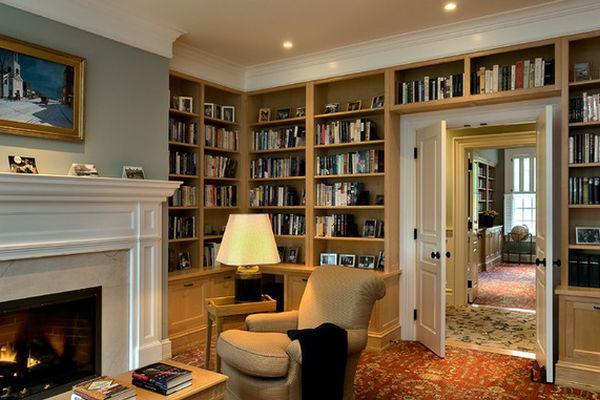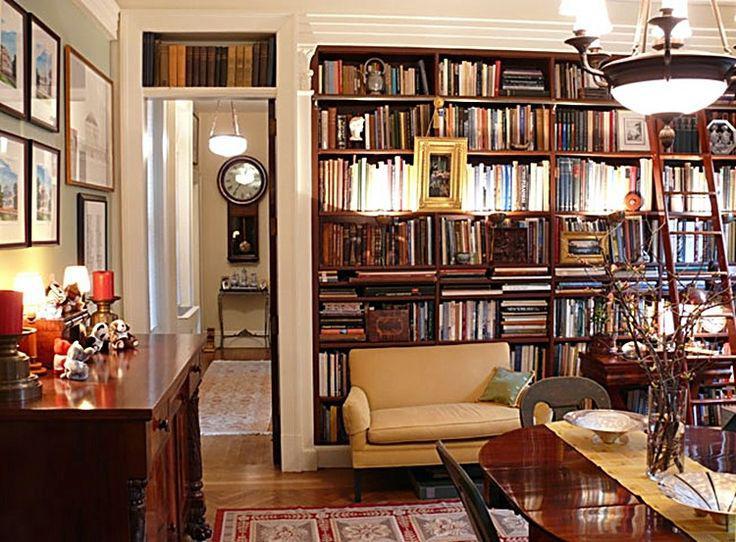The first image is the image on the left, the second image is the image on the right. Analyze the images presented: Is the assertion "There are at most three picture frames." valid? Answer yes or no. No. The first image is the image on the left, the second image is the image on the right. Given the left and right images, does the statement "In at least one image there is a cream colored sofa chair with a dark blanket folded and draped over the sofa chair with a yellow lamp to the left of the chair." hold true? Answer yes or no. Yes. 